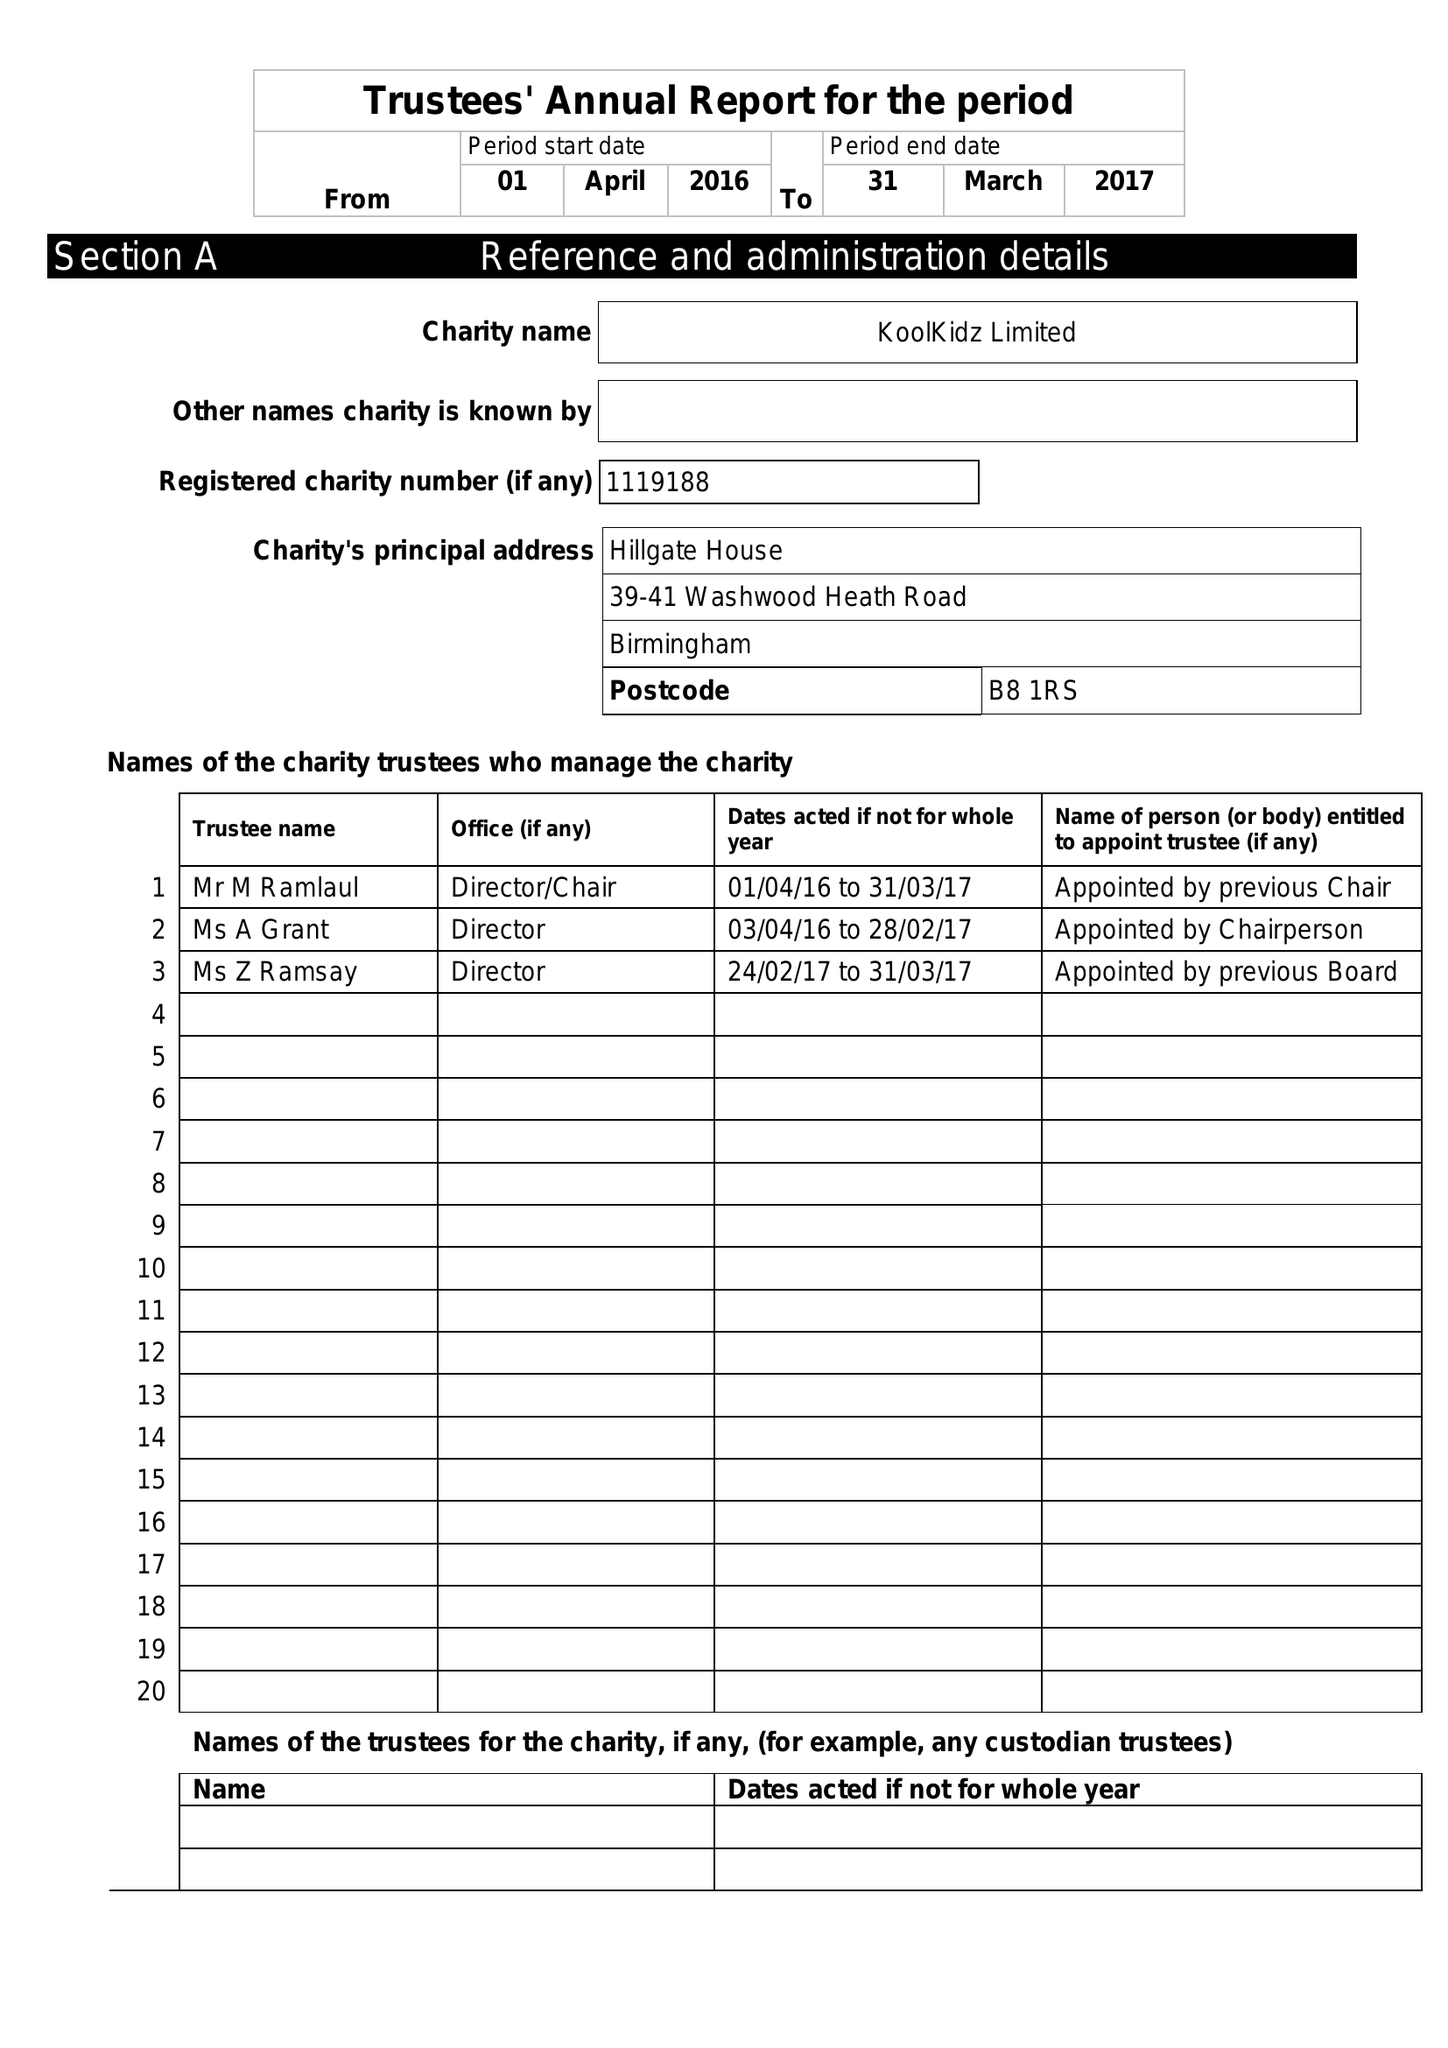What is the value for the charity_number?
Answer the question using a single word or phrase. 1119188 